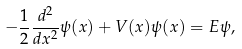Convert formula to latex. <formula><loc_0><loc_0><loc_500><loc_500>- \frac { 1 } { 2 } \frac { d ^ { 2 } } { d x ^ { 2 } } \psi ( x ) + V ( x ) \psi ( x ) = E \psi ,</formula> 